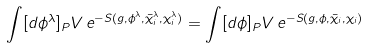<formula> <loc_0><loc_0><loc_500><loc_500>\int [ d \phi ^ { \lambda } ] _ { P } V \, e ^ { - S ( g , \phi ^ { \lambda } , \bar { \chi } _ { i } ^ { \lambda } , \chi _ { i } ^ { \lambda } ) } = \int [ d \phi ] _ { P } V \, e ^ { - S ( g , \phi , \bar { \chi } _ { i } , \chi _ { i } ) }</formula> 